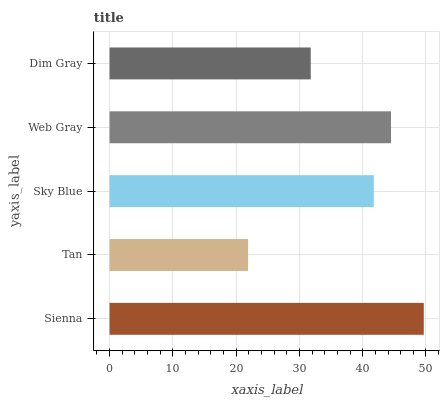Is Tan the minimum?
Answer yes or no. Yes. Is Sienna the maximum?
Answer yes or no. Yes. Is Sky Blue the minimum?
Answer yes or no. No. Is Sky Blue the maximum?
Answer yes or no. No. Is Sky Blue greater than Tan?
Answer yes or no. Yes. Is Tan less than Sky Blue?
Answer yes or no. Yes. Is Tan greater than Sky Blue?
Answer yes or no. No. Is Sky Blue less than Tan?
Answer yes or no. No. Is Sky Blue the high median?
Answer yes or no. Yes. Is Sky Blue the low median?
Answer yes or no. Yes. Is Dim Gray the high median?
Answer yes or no. No. Is Dim Gray the low median?
Answer yes or no. No. 